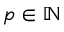<formula> <loc_0><loc_0><loc_500><loc_500>p \in \mathbb { N }</formula> 